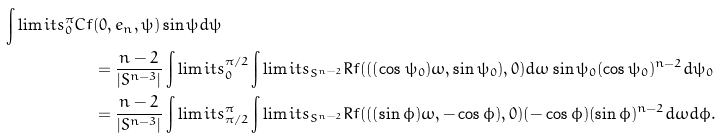<formula> <loc_0><loc_0><loc_500><loc_500>\int \lim i t s _ { 0 } ^ { \pi } C f & ( 0 , e _ { n } , \psi ) \sin \psi d \psi \\ & = \frac { n - 2 } { | S ^ { n - 3 } | } \int \lim i t s _ { 0 } ^ { \pi / 2 } \int \lim i t s _ { S ^ { n - 2 } } R f ( ( ( \cos \psi _ { 0 } ) \omega , \sin \psi _ { 0 } ) , 0 ) d \omega \sin \psi _ { 0 } ( \cos \psi _ { 0 } ) ^ { n - 2 } d \psi _ { 0 } \\ & = \frac { n - 2 } { | S ^ { n - 3 } | } \int \lim i t s _ { \pi / 2 } ^ { \pi } \int \lim i t s _ { S ^ { n - 2 } } R f ( ( ( \sin \phi ) \omega , - \cos \phi ) , 0 ) ( - \cos \phi ) ( \sin \phi ) ^ { n - 2 } d \omega d \phi .</formula> 